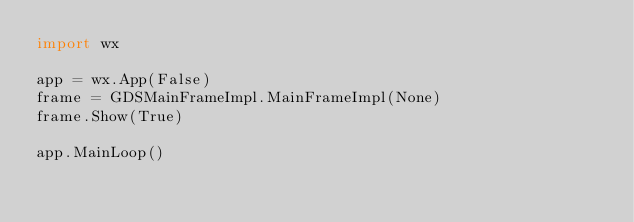Convert code to text. <code><loc_0><loc_0><loc_500><loc_500><_Python_>import wx

app = wx.App(False)
frame = GDSMainFrameImpl.MainFrameImpl(None)
frame.Show(True)

app.MainLoop()
</code> 